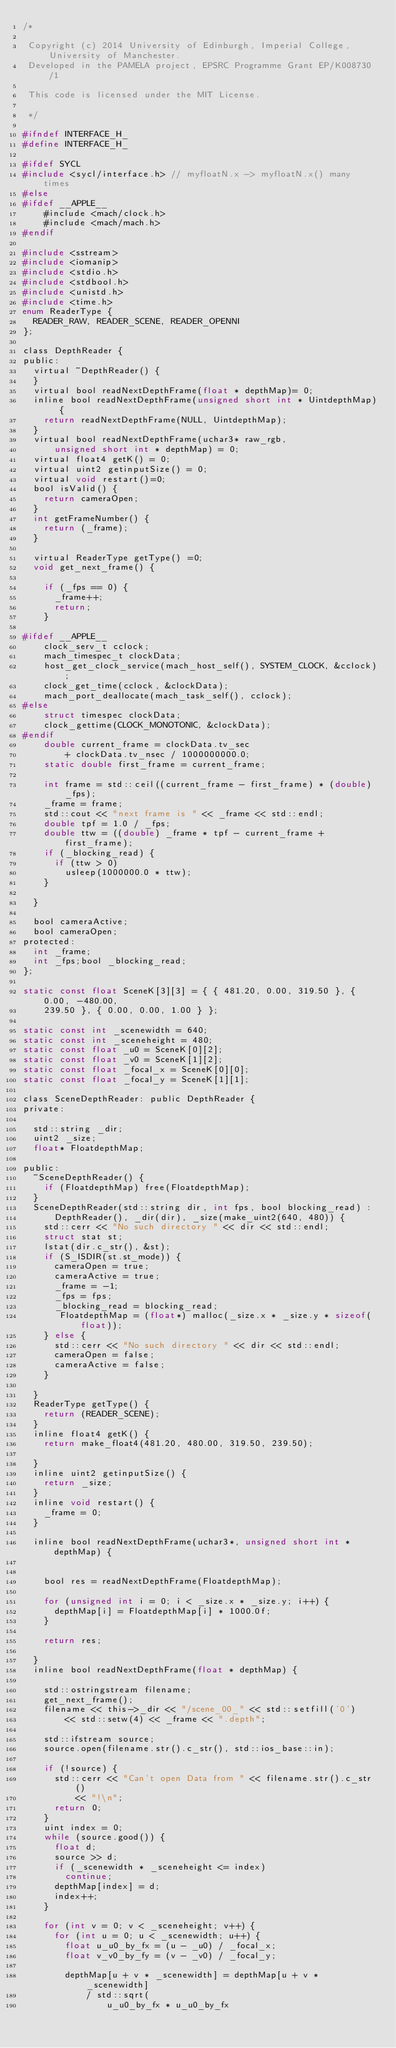Convert code to text. <code><loc_0><loc_0><loc_500><loc_500><_C_>/*

 Copyright (c) 2014 University of Edinburgh, Imperial College, University of Manchester.
 Developed in the PAMELA project, EPSRC Programme Grant EP/K008730/1

 This code is licensed under the MIT License.

 */

#ifndef INTERFACE_H_
#define INTERFACE_H_

#ifdef SYCL
#include <sycl/interface.h> // myfloatN.x -> myfloatN.x() many times
#else
#ifdef __APPLE__
    #include <mach/clock.h>
    #include <mach/mach.h>
#endif

#include <sstream>
#include <iomanip>
#include <stdio.h>
#include <stdbool.h>
#include <unistd.h>
#include <time.h>
enum ReaderType {
	READER_RAW, READER_SCENE, READER_OPENNI
};

class DepthReader {
public:
	virtual ~DepthReader() {
	}
	virtual bool readNextDepthFrame(float * depthMap)= 0;
	inline bool readNextDepthFrame(unsigned short int * UintdepthMap) {
		return readNextDepthFrame(NULL, UintdepthMap);
	}
	virtual bool readNextDepthFrame(uchar3* raw_rgb,
			unsigned short int * depthMap) = 0;
	virtual float4 getK() = 0;
	virtual uint2 getinputSize() = 0;
	virtual void restart()=0;
	bool isValid() {
		return cameraOpen;
	}
	int getFrameNumber() {
		return (_frame);
	}

	virtual ReaderType getType() =0;
	void get_next_frame() {

		if (_fps == 0) {
			_frame++;
			return;
		}

#ifdef __APPLE__
		clock_serv_t cclock;
		mach_timespec_t clockData;
		host_get_clock_service(mach_host_self(), SYSTEM_CLOCK, &cclock);
		clock_get_time(cclock, &clockData);
		mach_port_deallocate(mach_task_self(), cclock);
#else
		struct timespec clockData;
		clock_gettime(CLOCK_MONOTONIC, &clockData);
#endif
		double current_frame = clockData.tv_sec
				+ clockData.tv_nsec / 1000000000.0;
		static double first_frame = current_frame;

		int frame = std::ceil((current_frame - first_frame) * (double) _fps);
		_frame = frame;
		std::cout << "next frame is " << _frame << std::endl;
		double tpf = 1.0 / _fps;
		double ttw = ((double) _frame * tpf - current_frame + first_frame);
		if (_blocking_read) {
			if (ttw > 0)
				usleep(1000000.0 * ttw);
		}

	}

	bool cameraActive;
	bool cameraOpen;
protected:
	int _frame;
	int _fps;bool _blocking_read;
};

static const float SceneK[3][3] = { { 481.20, 0.00, 319.50 }, { 0.00, -480.00,
		239.50 }, { 0.00, 0.00, 1.00 } };

static const int _scenewidth = 640;
static const int _sceneheight = 480;
static const float _u0 = SceneK[0][2];
static const float _v0 = SceneK[1][2];
static const float _focal_x = SceneK[0][0];
static const float _focal_y = SceneK[1][1];

class SceneDepthReader: public DepthReader {
private:

	std::string _dir;
	uint2 _size;
	float* FloatdepthMap;

public:
	~SceneDepthReader() {
	  if (FloatdepthMap) free(FloatdepthMap);
	}
	SceneDepthReader(std::string dir, int fps, bool blocking_read) :
			DepthReader(), _dir(dir), _size(make_uint2(640, 480)) {
		std::cerr << "No such directory " << dir << std::endl;
		struct stat st;
		lstat(dir.c_str(), &st);
		if (S_ISDIR(st.st_mode)) {
			cameraOpen = true;
			cameraActive = true;
			_frame = -1;
			_fps = fps;
			_blocking_read = blocking_read;
			 FloatdepthMap = (float*) malloc(_size.x * _size.y * sizeof(float));
		} else {
			std::cerr << "No such directory " << dir << std::endl;
			cameraOpen = false;
			cameraActive = false;
		}

	}
	ReaderType getType() {
		return (READER_SCENE);
	}
	inline float4 getK() {
		return make_float4(481.20, 480.00, 319.50, 239.50);

	}
	inline uint2 getinputSize() {
		return _size;
	}
	inline void restart() {
		_frame = 0;
	}

	inline bool readNextDepthFrame(uchar3*, unsigned short int * depthMap) {


		bool res = readNextDepthFrame(FloatdepthMap);

		for (unsigned int i = 0; i < _size.x * _size.y; i++) {
			depthMap[i] = FloatdepthMap[i] * 1000.0f;
		}

		return res;

	}
	inline bool readNextDepthFrame(float * depthMap) {

		std::ostringstream filename;
		get_next_frame();
		filename << this->_dir << "/scene_00_" << std::setfill('0')
				<< std::setw(4) << _frame << ".depth";

		std::ifstream source;
		source.open(filename.str().c_str(), std::ios_base::in);

		if (!source) {
			std::cerr << "Can't open Data from " << filename.str().c_str()
					<< "!\n";
			return 0;
		}
		uint index = 0;
		while (source.good()) {
			float d;
			source >> d;
			if (_scenewidth * _sceneheight <= index)
				continue;
			depthMap[index] = d;
			index++;
		}

		for (int v = 0; v < _sceneheight; v++) {
			for (int u = 0; u < _scenewidth; u++) {
				float u_u0_by_fx = (u - _u0) / _focal_x;
				float v_v0_by_fy = (v - _v0) / _focal_y;

				depthMap[u + v * _scenewidth] = depthMap[u + v * _scenewidth]
						/ std::sqrt(
								u_u0_by_fx * u_u0_by_fx</code> 